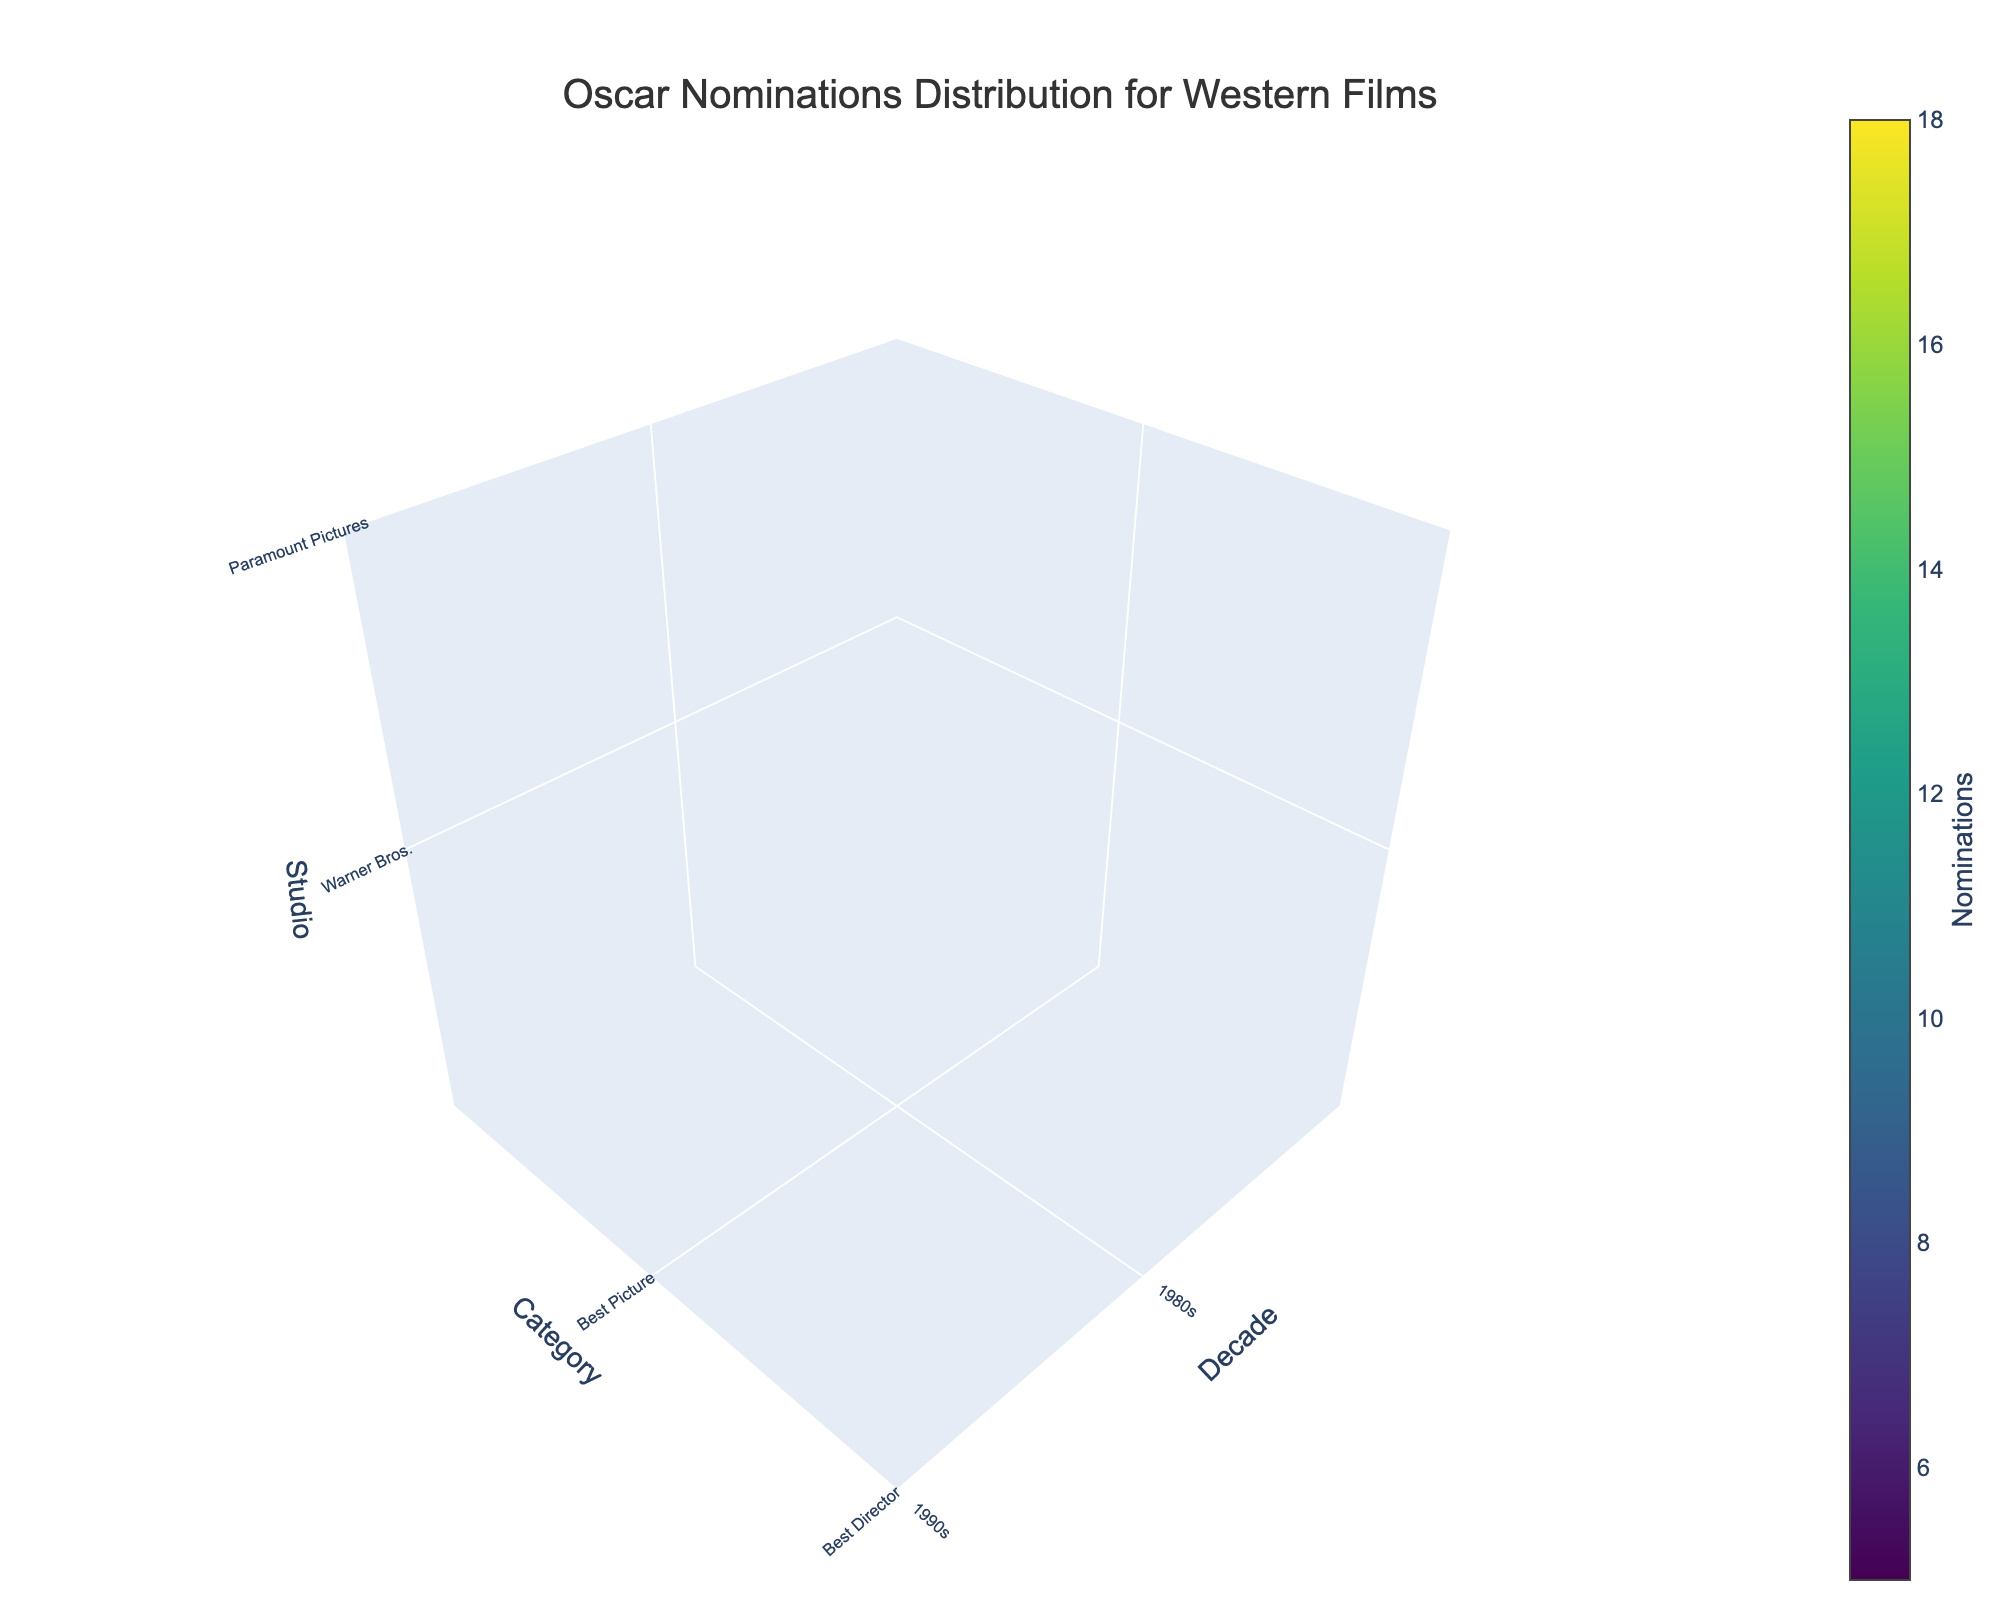How many decades are represented in the plot? The plot includes data points on the x-axis labeled "Decade," and we can count the distinct decades present. From the title "Oscar Nominations Distribution for Western Films", the figure includes the 1980s, 1990s, 2000s, and 2010s.
Answer: 4 Which studio received the highest number of nominations for Best Picture in the 2000s? By observing the z-axis labeled "Studio" and cross-referencing with the y-axis labeled "Category" for "Best Picture" and the x-axis "2000s", we see "Universal Pictures" has the highest point in that category and decade.
Answer: Universal Pictures What is the total number of nominations for "Best Director" from all studios combined in the 2010s? Locate the y-axis for "Category" set to "Best Director" and the x-axis for "Decade" set to "2010s". The z-axis corresponding to this category and decade shows values. Add the nominations: The Weinstein Company (9). Hence, the total is 9.
Answer: 9 Which category received the least nominations overall in the 1980s? Scan the y-axis for all categories, and for each category, sum the z-axis "Nominations" values in the 1980s as indicated by the x-axis. "Best Screenplay" with United Artists has the lowest nomination count of 5.
Answer: Best Screenplay Compare the total nominations for "Best Actor" and "Best Actress" in the 2000s. Which category received more nominations? For "Best Actor" in the 2000s (Focus Features) with 12 and "Best Actress" in the 2000s (Fox Searchlight Pictures) with 11, sum the z-values associated with respective studios and compare. The sums are: Best Actor (12), Best Actress (11).
Answer: Best Actor Which decade had the most nominations overall? By adding all the nominations per decade, the sums are: 1980s (38), 1990s (53), 2000s (64), 2010s (44). The 2000s had the highest total nominations.
Answer: 2000s Which studio received the highest number of nominations across all decades and categories? Sum the nominations of each studio across all categories and decades: Warner Bros. (12), Paramount Pictures (15), Universal Pictures (18), 20th Century Fox (14), Columbia Pictures (8), Miramax Films (11), DreamWorks Pictures (13), The Weinstein Company (9), MGM (7), TriStar Pictures (10), Focus Features (12), Lionsgate (8), Orion Pictures (6), New Line Cinema (9), Fox Searchlight Pictures (11), Sony Pictures Classics (7), United Artists (5), Walt Disney Pictures (8), Summit Entertainment (10), A24 (6). Universal Pictures has the highest total with 18.
Answer: Universal Pictures What is the average number of nominations for the "Best Screenplay" category across all decades? Add the nominations for "Best Screenplay" across all decades: 1980s (5), 1990s (8), 2000s (10), 2010s (6). The sum is 29, and with 4 decades, the average is 29/4 = 7.25.
Answer: 7.25 